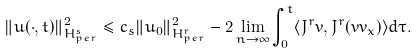Convert formula to latex. <formula><loc_0><loc_0><loc_500><loc_500>\| u ( \cdot , t ) \| ^ { 2 } _ { H _ { p e r } ^ { s } } \leq c _ { s } \| u _ { 0 } \| ^ { 2 } _ { H _ { p e r } ^ { r } } - 2 \lim _ { n \rightarrow \infty } \int _ { 0 } ^ { t } \langle J ^ { r } v , J ^ { r } ( v v _ { x } ) \rangle d \tau .</formula> 